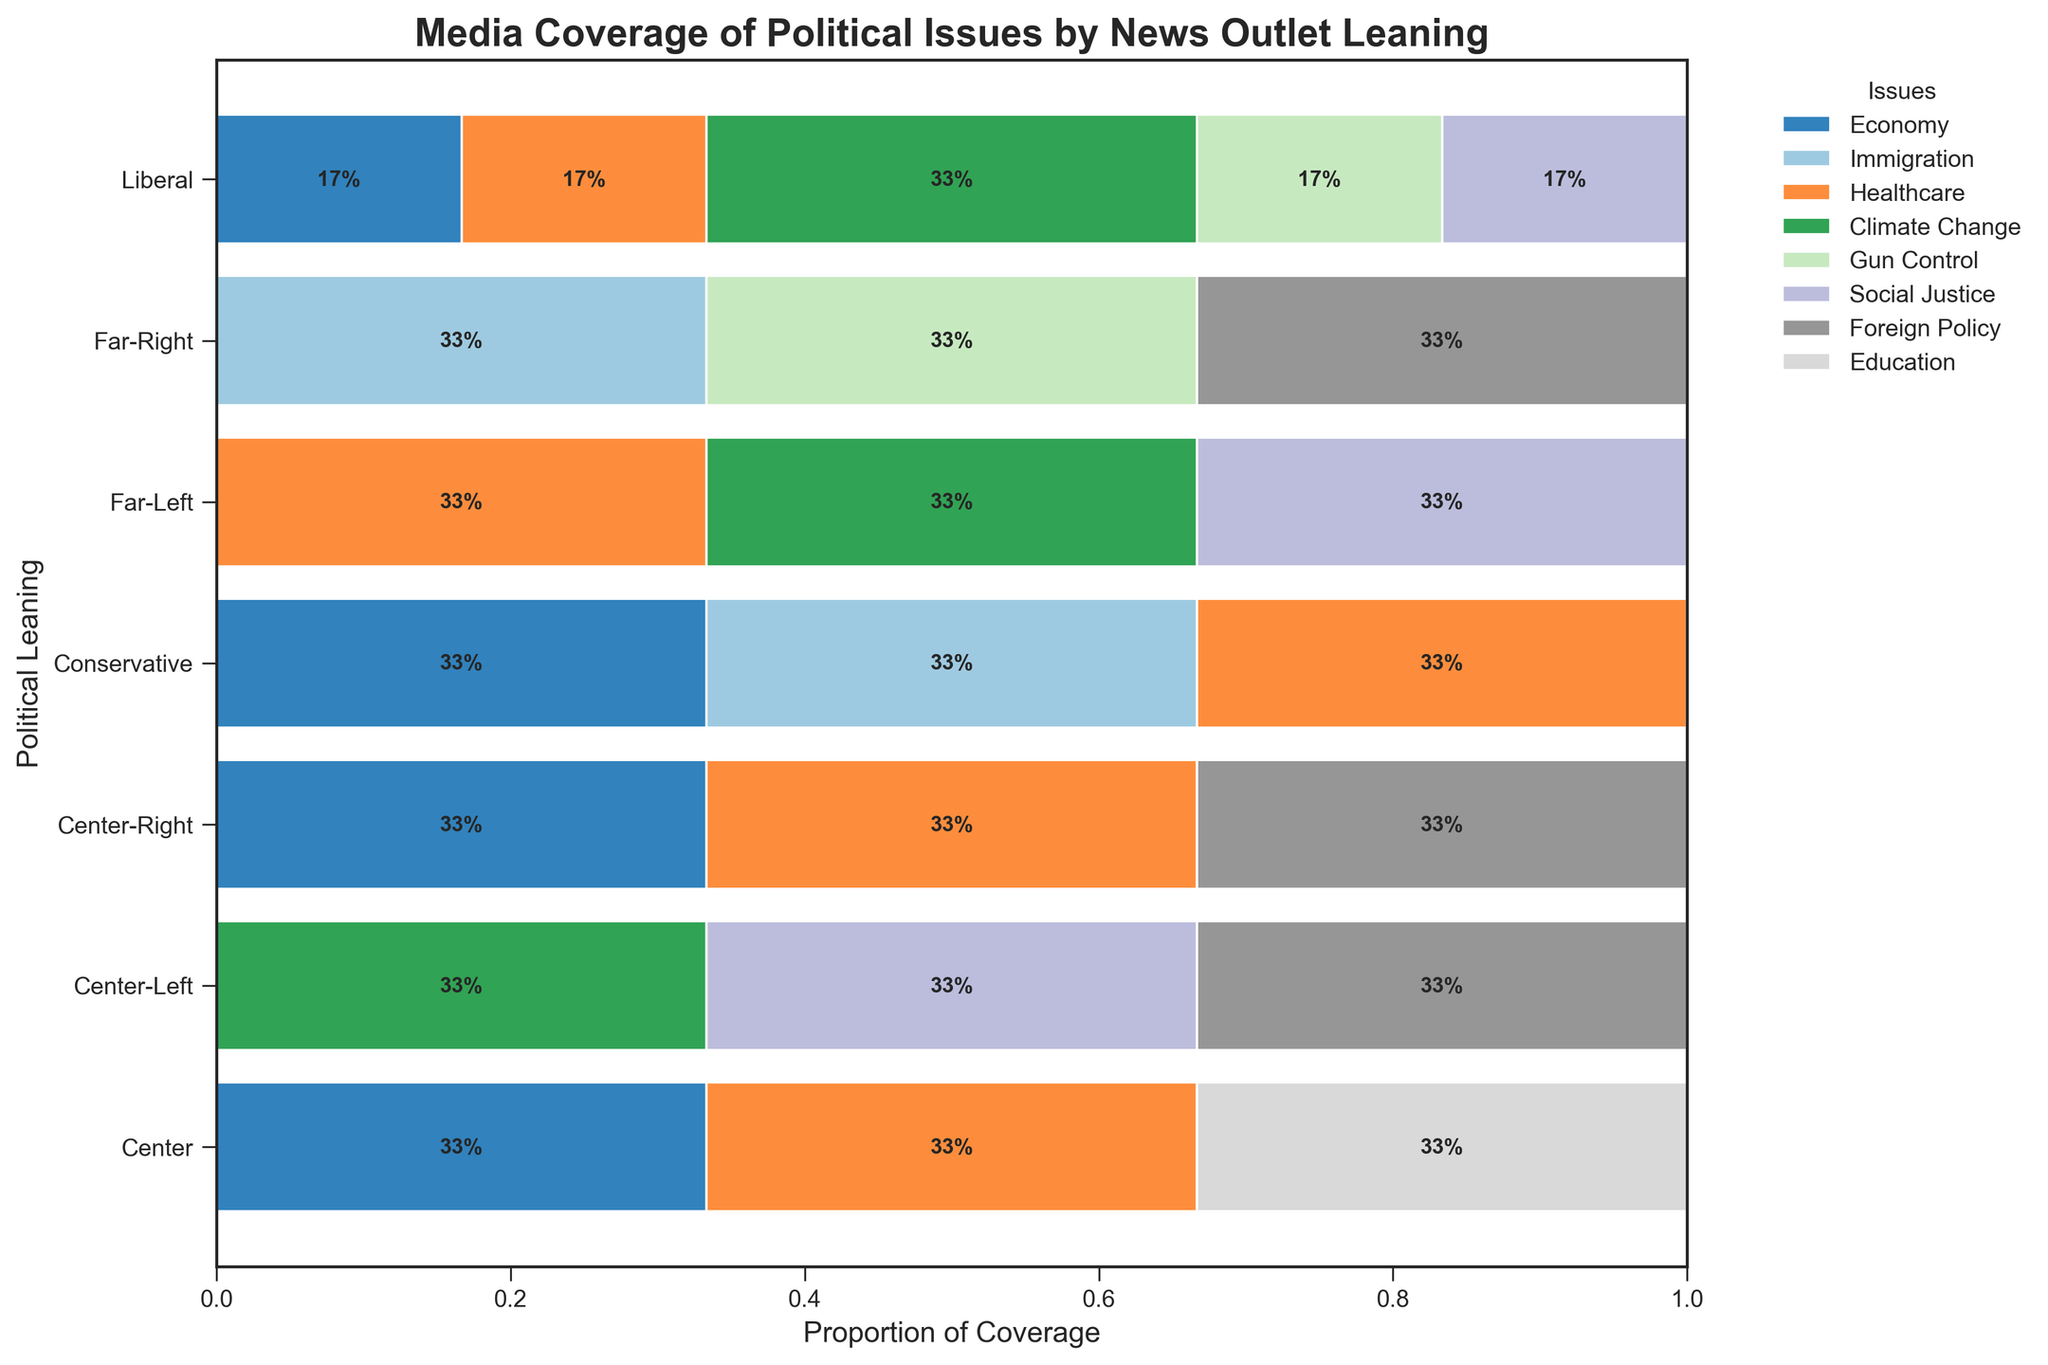What's the title of the figure? The figure's title is usually located at the top, indicating the subject matter of the visualization. It reads "Media Coverage of Political Issues by News Outlet Leaning."
Answer: Media Coverage of Political Issues by News Outlet Leaning Which political leaning has the highest proportion of coverage on Social Justice issues? From the horizontal bar plot, we see that the Far-Left political leaning has the largest portion of its bar colored, representing Social Justice.
Answer: Far-Left Among the issues covered by NPR, which one has the smallest proportion? By examining NPR's row, the smallest segment visible is the one for Education.
Answer: Education How does the coverage of Immigration by Conservative outlets compare to Far-Right outlets? Conservative outlets (e.g., Fox News) have a visible segment for Immigration but smaller in proportion compared to Far-Right outlets (e.g., Breitbart), which have a more significant segment for Immigration coverage.
Answer: Far-Right has more coverage What issues are most prominently covered by Center-Left outlets? By observing the Center-Left row, it's clear that Climate Change and Social Justice have the most significant segments, indicating higher coverage.
Answer: Climate Change and Social Justice Which issue is given the least coverage across all political leanings? Reviewing all rows, the segment for Education is generally the smallest across columns, making it the least covered issue.
Answer: Education Compare the coverage percentages of Healthcare between Center and Center-Right outlets? The Healthcare segment in the Center row is significant, while the one in the Center-Right row is smaller; thus Center outlets cover Healthcare more extensively.
Answer: Center has more coverage For Liberal outlets, which two issues are covered nearly equally? In the Liberal row, Climate Change and Healthcare appear to have similarly sized segments, indicating nearly equal coverage proportions.
Answer: Climate Change and Healthcare What proportion of Gun Control coverage does Far-Left outlets have compared to Liberal outlets? The Far-Left row shows no visible segment for Gun Control, while the Liberal row has a noticeable segment. Therefore, Far-Left has less or no coverage compared to Liberal outlets.
Answer: Far-Left has less coverage 